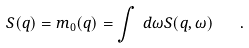<formula> <loc_0><loc_0><loc_500><loc_500>S ( q ) = m _ { 0 } ( q ) = \int \, d \omega S ( q , \omega ) \quad .</formula> 